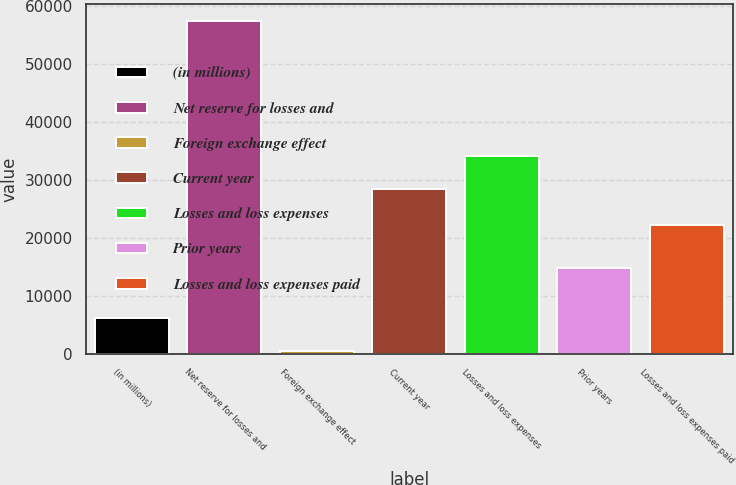Convert chart to OTSL. <chart><loc_0><loc_0><loc_500><loc_500><bar_chart><fcel>(in millions)<fcel>Net reserve for losses and<fcel>Foreign exchange effect<fcel>Current year<fcel>Losses and loss expenses<fcel>Prior years<fcel>Losses and loss expenses paid<nl><fcel>6312.8<fcel>57476<fcel>628<fcel>28426<fcel>34110.8<fcel>14910<fcel>22241<nl></chart> 